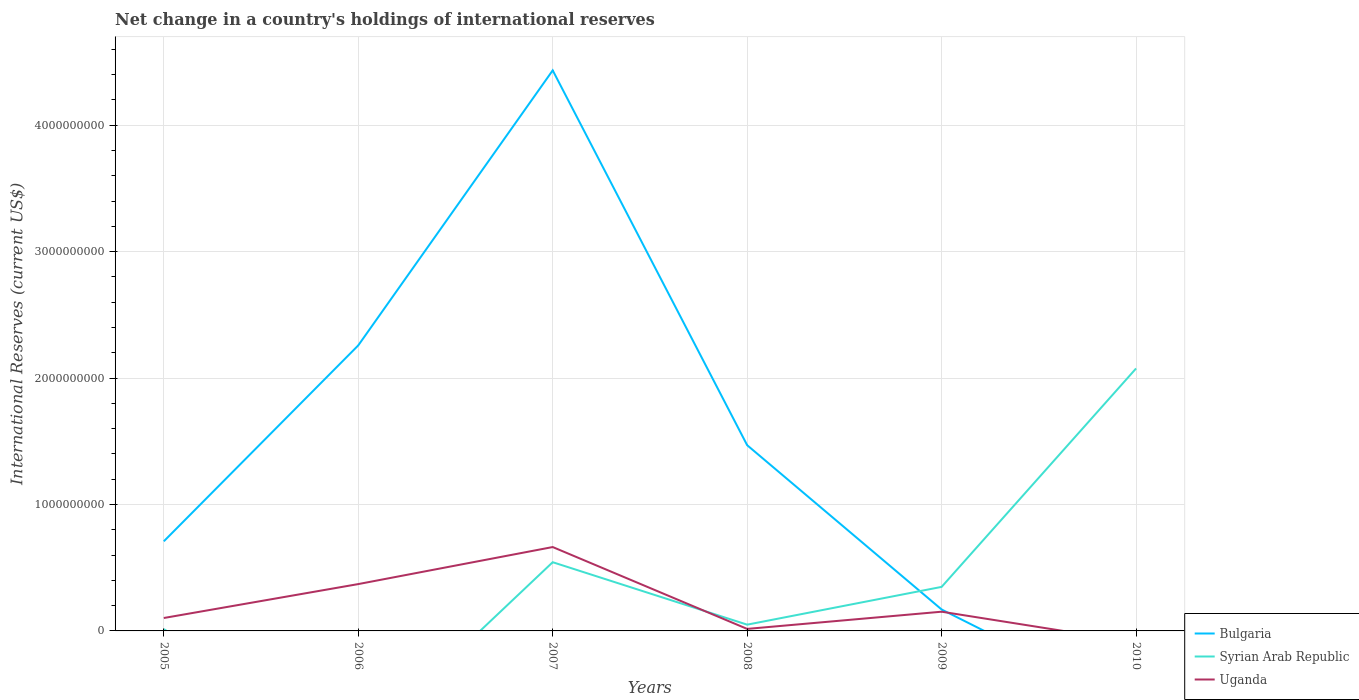Does the line corresponding to Syrian Arab Republic intersect with the line corresponding to Bulgaria?
Provide a succinct answer. Yes. Is the number of lines equal to the number of legend labels?
Provide a short and direct response. No. Across all years, what is the maximum international reserves in Uganda?
Keep it short and to the point. 0. What is the total international reserves in Syrian Arab Republic in the graph?
Keep it short and to the point. -3.56e+07. What is the difference between the highest and the second highest international reserves in Uganda?
Make the answer very short. 6.64e+08. Is the international reserves in Bulgaria strictly greater than the international reserves in Syrian Arab Republic over the years?
Make the answer very short. No. How many years are there in the graph?
Provide a succinct answer. 6. Are the values on the major ticks of Y-axis written in scientific E-notation?
Give a very brief answer. No. Does the graph contain any zero values?
Ensure brevity in your answer.  Yes. Where does the legend appear in the graph?
Offer a very short reply. Bottom right. How many legend labels are there?
Your answer should be compact. 3. How are the legend labels stacked?
Offer a very short reply. Vertical. What is the title of the graph?
Provide a succinct answer. Net change in a country's holdings of international reserves. Does "French Polynesia" appear as one of the legend labels in the graph?
Offer a very short reply. No. What is the label or title of the X-axis?
Ensure brevity in your answer.  Years. What is the label or title of the Y-axis?
Offer a terse response. International Reserves (current US$). What is the International Reserves (current US$) in Bulgaria in 2005?
Offer a very short reply. 7.09e+08. What is the International Reserves (current US$) of Syrian Arab Republic in 2005?
Ensure brevity in your answer.  1.40e+07. What is the International Reserves (current US$) of Uganda in 2005?
Give a very brief answer. 1.02e+08. What is the International Reserves (current US$) of Bulgaria in 2006?
Your response must be concise. 2.26e+09. What is the International Reserves (current US$) in Uganda in 2006?
Give a very brief answer. 3.70e+08. What is the International Reserves (current US$) in Bulgaria in 2007?
Provide a short and direct response. 4.43e+09. What is the International Reserves (current US$) of Syrian Arab Republic in 2007?
Ensure brevity in your answer.  5.44e+08. What is the International Reserves (current US$) in Uganda in 2007?
Your response must be concise. 6.64e+08. What is the International Reserves (current US$) in Bulgaria in 2008?
Offer a very short reply. 1.47e+09. What is the International Reserves (current US$) of Syrian Arab Republic in 2008?
Ensure brevity in your answer.  4.96e+07. What is the International Reserves (current US$) in Uganda in 2008?
Offer a terse response. 1.59e+07. What is the International Reserves (current US$) of Bulgaria in 2009?
Provide a short and direct response. 1.69e+08. What is the International Reserves (current US$) in Syrian Arab Republic in 2009?
Offer a very short reply. 3.48e+08. What is the International Reserves (current US$) of Uganda in 2009?
Make the answer very short. 1.52e+08. What is the International Reserves (current US$) in Bulgaria in 2010?
Your response must be concise. 0. What is the International Reserves (current US$) in Syrian Arab Republic in 2010?
Make the answer very short. 2.08e+09. Across all years, what is the maximum International Reserves (current US$) in Bulgaria?
Offer a terse response. 4.43e+09. Across all years, what is the maximum International Reserves (current US$) of Syrian Arab Republic?
Offer a very short reply. 2.08e+09. Across all years, what is the maximum International Reserves (current US$) of Uganda?
Ensure brevity in your answer.  6.64e+08. Across all years, what is the minimum International Reserves (current US$) of Bulgaria?
Provide a short and direct response. 0. Across all years, what is the minimum International Reserves (current US$) in Syrian Arab Republic?
Offer a terse response. 0. Across all years, what is the minimum International Reserves (current US$) in Uganda?
Ensure brevity in your answer.  0. What is the total International Reserves (current US$) of Bulgaria in the graph?
Ensure brevity in your answer.  9.04e+09. What is the total International Reserves (current US$) of Syrian Arab Republic in the graph?
Your response must be concise. 3.03e+09. What is the total International Reserves (current US$) of Uganda in the graph?
Keep it short and to the point. 1.30e+09. What is the difference between the International Reserves (current US$) in Bulgaria in 2005 and that in 2006?
Keep it short and to the point. -1.55e+09. What is the difference between the International Reserves (current US$) of Uganda in 2005 and that in 2006?
Provide a succinct answer. -2.68e+08. What is the difference between the International Reserves (current US$) of Bulgaria in 2005 and that in 2007?
Give a very brief answer. -3.73e+09. What is the difference between the International Reserves (current US$) in Syrian Arab Republic in 2005 and that in 2007?
Your answer should be very brief. -5.30e+08. What is the difference between the International Reserves (current US$) of Uganda in 2005 and that in 2007?
Offer a very short reply. -5.61e+08. What is the difference between the International Reserves (current US$) in Bulgaria in 2005 and that in 2008?
Ensure brevity in your answer.  -7.60e+08. What is the difference between the International Reserves (current US$) of Syrian Arab Republic in 2005 and that in 2008?
Give a very brief answer. -3.56e+07. What is the difference between the International Reserves (current US$) in Uganda in 2005 and that in 2008?
Offer a terse response. 8.63e+07. What is the difference between the International Reserves (current US$) in Bulgaria in 2005 and that in 2009?
Offer a terse response. 5.39e+08. What is the difference between the International Reserves (current US$) in Syrian Arab Republic in 2005 and that in 2009?
Make the answer very short. -3.34e+08. What is the difference between the International Reserves (current US$) in Uganda in 2005 and that in 2009?
Provide a succinct answer. -4.98e+07. What is the difference between the International Reserves (current US$) in Syrian Arab Republic in 2005 and that in 2010?
Your answer should be compact. -2.06e+09. What is the difference between the International Reserves (current US$) in Bulgaria in 2006 and that in 2007?
Ensure brevity in your answer.  -2.18e+09. What is the difference between the International Reserves (current US$) of Uganda in 2006 and that in 2007?
Your response must be concise. -2.93e+08. What is the difference between the International Reserves (current US$) of Bulgaria in 2006 and that in 2008?
Make the answer very short. 7.89e+08. What is the difference between the International Reserves (current US$) in Uganda in 2006 and that in 2008?
Provide a succinct answer. 3.55e+08. What is the difference between the International Reserves (current US$) in Bulgaria in 2006 and that in 2009?
Give a very brief answer. 2.09e+09. What is the difference between the International Reserves (current US$) in Uganda in 2006 and that in 2009?
Offer a very short reply. 2.19e+08. What is the difference between the International Reserves (current US$) of Bulgaria in 2007 and that in 2008?
Provide a succinct answer. 2.97e+09. What is the difference between the International Reserves (current US$) of Syrian Arab Republic in 2007 and that in 2008?
Give a very brief answer. 4.94e+08. What is the difference between the International Reserves (current US$) in Uganda in 2007 and that in 2008?
Make the answer very short. 6.48e+08. What is the difference between the International Reserves (current US$) of Bulgaria in 2007 and that in 2009?
Provide a succinct answer. 4.26e+09. What is the difference between the International Reserves (current US$) of Syrian Arab Republic in 2007 and that in 2009?
Your answer should be very brief. 1.95e+08. What is the difference between the International Reserves (current US$) in Uganda in 2007 and that in 2009?
Your answer should be very brief. 5.12e+08. What is the difference between the International Reserves (current US$) of Syrian Arab Republic in 2007 and that in 2010?
Offer a terse response. -1.53e+09. What is the difference between the International Reserves (current US$) in Bulgaria in 2008 and that in 2009?
Provide a succinct answer. 1.30e+09. What is the difference between the International Reserves (current US$) in Syrian Arab Republic in 2008 and that in 2009?
Provide a short and direct response. -2.99e+08. What is the difference between the International Reserves (current US$) in Uganda in 2008 and that in 2009?
Provide a short and direct response. -1.36e+08. What is the difference between the International Reserves (current US$) in Syrian Arab Republic in 2008 and that in 2010?
Your response must be concise. -2.03e+09. What is the difference between the International Reserves (current US$) in Syrian Arab Republic in 2009 and that in 2010?
Provide a succinct answer. -1.73e+09. What is the difference between the International Reserves (current US$) in Bulgaria in 2005 and the International Reserves (current US$) in Uganda in 2006?
Give a very brief answer. 3.38e+08. What is the difference between the International Reserves (current US$) in Syrian Arab Republic in 2005 and the International Reserves (current US$) in Uganda in 2006?
Offer a very short reply. -3.57e+08. What is the difference between the International Reserves (current US$) in Bulgaria in 2005 and the International Reserves (current US$) in Syrian Arab Republic in 2007?
Provide a succinct answer. 1.65e+08. What is the difference between the International Reserves (current US$) in Bulgaria in 2005 and the International Reserves (current US$) in Uganda in 2007?
Your answer should be very brief. 4.52e+07. What is the difference between the International Reserves (current US$) of Syrian Arab Republic in 2005 and the International Reserves (current US$) of Uganda in 2007?
Ensure brevity in your answer.  -6.50e+08. What is the difference between the International Reserves (current US$) in Bulgaria in 2005 and the International Reserves (current US$) in Syrian Arab Republic in 2008?
Offer a very short reply. 6.59e+08. What is the difference between the International Reserves (current US$) in Bulgaria in 2005 and the International Reserves (current US$) in Uganda in 2008?
Offer a terse response. 6.93e+08. What is the difference between the International Reserves (current US$) of Syrian Arab Republic in 2005 and the International Reserves (current US$) of Uganda in 2008?
Give a very brief answer. -1.92e+06. What is the difference between the International Reserves (current US$) in Bulgaria in 2005 and the International Reserves (current US$) in Syrian Arab Republic in 2009?
Ensure brevity in your answer.  3.60e+08. What is the difference between the International Reserves (current US$) in Bulgaria in 2005 and the International Reserves (current US$) in Uganda in 2009?
Give a very brief answer. 5.57e+08. What is the difference between the International Reserves (current US$) of Syrian Arab Republic in 2005 and the International Reserves (current US$) of Uganda in 2009?
Provide a succinct answer. -1.38e+08. What is the difference between the International Reserves (current US$) of Bulgaria in 2005 and the International Reserves (current US$) of Syrian Arab Republic in 2010?
Your answer should be compact. -1.37e+09. What is the difference between the International Reserves (current US$) in Bulgaria in 2006 and the International Reserves (current US$) in Syrian Arab Republic in 2007?
Offer a terse response. 1.72e+09. What is the difference between the International Reserves (current US$) of Bulgaria in 2006 and the International Reserves (current US$) of Uganda in 2007?
Your response must be concise. 1.60e+09. What is the difference between the International Reserves (current US$) of Bulgaria in 2006 and the International Reserves (current US$) of Syrian Arab Republic in 2008?
Give a very brief answer. 2.21e+09. What is the difference between the International Reserves (current US$) in Bulgaria in 2006 and the International Reserves (current US$) in Uganda in 2008?
Offer a terse response. 2.24e+09. What is the difference between the International Reserves (current US$) in Bulgaria in 2006 and the International Reserves (current US$) in Syrian Arab Republic in 2009?
Make the answer very short. 1.91e+09. What is the difference between the International Reserves (current US$) of Bulgaria in 2006 and the International Reserves (current US$) of Uganda in 2009?
Provide a succinct answer. 2.11e+09. What is the difference between the International Reserves (current US$) in Bulgaria in 2006 and the International Reserves (current US$) in Syrian Arab Republic in 2010?
Give a very brief answer. 1.82e+08. What is the difference between the International Reserves (current US$) in Bulgaria in 2007 and the International Reserves (current US$) in Syrian Arab Republic in 2008?
Make the answer very short. 4.38e+09. What is the difference between the International Reserves (current US$) in Bulgaria in 2007 and the International Reserves (current US$) in Uganda in 2008?
Your answer should be compact. 4.42e+09. What is the difference between the International Reserves (current US$) of Syrian Arab Republic in 2007 and the International Reserves (current US$) of Uganda in 2008?
Keep it short and to the point. 5.28e+08. What is the difference between the International Reserves (current US$) of Bulgaria in 2007 and the International Reserves (current US$) of Syrian Arab Republic in 2009?
Provide a succinct answer. 4.09e+09. What is the difference between the International Reserves (current US$) of Bulgaria in 2007 and the International Reserves (current US$) of Uganda in 2009?
Your response must be concise. 4.28e+09. What is the difference between the International Reserves (current US$) of Syrian Arab Republic in 2007 and the International Reserves (current US$) of Uganda in 2009?
Keep it short and to the point. 3.92e+08. What is the difference between the International Reserves (current US$) in Bulgaria in 2007 and the International Reserves (current US$) in Syrian Arab Republic in 2010?
Keep it short and to the point. 2.36e+09. What is the difference between the International Reserves (current US$) in Bulgaria in 2008 and the International Reserves (current US$) in Syrian Arab Republic in 2009?
Your answer should be very brief. 1.12e+09. What is the difference between the International Reserves (current US$) of Bulgaria in 2008 and the International Reserves (current US$) of Uganda in 2009?
Provide a succinct answer. 1.32e+09. What is the difference between the International Reserves (current US$) of Syrian Arab Republic in 2008 and the International Reserves (current US$) of Uganda in 2009?
Provide a short and direct response. -1.02e+08. What is the difference between the International Reserves (current US$) in Bulgaria in 2008 and the International Reserves (current US$) in Syrian Arab Republic in 2010?
Ensure brevity in your answer.  -6.07e+08. What is the difference between the International Reserves (current US$) in Bulgaria in 2009 and the International Reserves (current US$) in Syrian Arab Republic in 2010?
Ensure brevity in your answer.  -1.91e+09. What is the average International Reserves (current US$) in Bulgaria per year?
Your response must be concise. 1.51e+09. What is the average International Reserves (current US$) of Syrian Arab Republic per year?
Your answer should be compact. 5.05e+08. What is the average International Reserves (current US$) in Uganda per year?
Keep it short and to the point. 2.17e+08. In the year 2005, what is the difference between the International Reserves (current US$) in Bulgaria and International Reserves (current US$) in Syrian Arab Republic?
Ensure brevity in your answer.  6.95e+08. In the year 2005, what is the difference between the International Reserves (current US$) in Bulgaria and International Reserves (current US$) in Uganda?
Your answer should be very brief. 6.07e+08. In the year 2005, what is the difference between the International Reserves (current US$) in Syrian Arab Republic and International Reserves (current US$) in Uganda?
Provide a succinct answer. -8.82e+07. In the year 2006, what is the difference between the International Reserves (current US$) of Bulgaria and International Reserves (current US$) of Uganda?
Offer a very short reply. 1.89e+09. In the year 2007, what is the difference between the International Reserves (current US$) of Bulgaria and International Reserves (current US$) of Syrian Arab Republic?
Offer a very short reply. 3.89e+09. In the year 2007, what is the difference between the International Reserves (current US$) in Bulgaria and International Reserves (current US$) in Uganda?
Provide a short and direct response. 3.77e+09. In the year 2007, what is the difference between the International Reserves (current US$) in Syrian Arab Republic and International Reserves (current US$) in Uganda?
Your answer should be very brief. -1.20e+08. In the year 2008, what is the difference between the International Reserves (current US$) in Bulgaria and International Reserves (current US$) in Syrian Arab Republic?
Keep it short and to the point. 1.42e+09. In the year 2008, what is the difference between the International Reserves (current US$) of Bulgaria and International Reserves (current US$) of Uganda?
Keep it short and to the point. 1.45e+09. In the year 2008, what is the difference between the International Reserves (current US$) of Syrian Arab Republic and International Reserves (current US$) of Uganda?
Ensure brevity in your answer.  3.36e+07. In the year 2009, what is the difference between the International Reserves (current US$) in Bulgaria and International Reserves (current US$) in Syrian Arab Republic?
Provide a succinct answer. -1.79e+08. In the year 2009, what is the difference between the International Reserves (current US$) of Bulgaria and International Reserves (current US$) of Uganda?
Provide a short and direct response. 1.75e+07. In the year 2009, what is the difference between the International Reserves (current US$) in Syrian Arab Republic and International Reserves (current US$) in Uganda?
Your answer should be compact. 1.96e+08. What is the ratio of the International Reserves (current US$) of Bulgaria in 2005 to that in 2006?
Ensure brevity in your answer.  0.31. What is the ratio of the International Reserves (current US$) of Uganda in 2005 to that in 2006?
Your answer should be very brief. 0.28. What is the ratio of the International Reserves (current US$) in Bulgaria in 2005 to that in 2007?
Your answer should be very brief. 0.16. What is the ratio of the International Reserves (current US$) of Syrian Arab Republic in 2005 to that in 2007?
Provide a succinct answer. 0.03. What is the ratio of the International Reserves (current US$) in Uganda in 2005 to that in 2007?
Provide a short and direct response. 0.15. What is the ratio of the International Reserves (current US$) of Bulgaria in 2005 to that in 2008?
Keep it short and to the point. 0.48. What is the ratio of the International Reserves (current US$) in Syrian Arab Republic in 2005 to that in 2008?
Offer a terse response. 0.28. What is the ratio of the International Reserves (current US$) of Uganda in 2005 to that in 2008?
Your answer should be very brief. 6.42. What is the ratio of the International Reserves (current US$) in Bulgaria in 2005 to that in 2009?
Offer a very short reply. 4.18. What is the ratio of the International Reserves (current US$) in Syrian Arab Republic in 2005 to that in 2009?
Your answer should be compact. 0.04. What is the ratio of the International Reserves (current US$) in Uganda in 2005 to that in 2009?
Keep it short and to the point. 0.67. What is the ratio of the International Reserves (current US$) of Syrian Arab Republic in 2005 to that in 2010?
Your response must be concise. 0.01. What is the ratio of the International Reserves (current US$) of Bulgaria in 2006 to that in 2007?
Offer a terse response. 0.51. What is the ratio of the International Reserves (current US$) of Uganda in 2006 to that in 2007?
Provide a succinct answer. 0.56. What is the ratio of the International Reserves (current US$) of Bulgaria in 2006 to that in 2008?
Keep it short and to the point. 1.54. What is the ratio of the International Reserves (current US$) in Uganda in 2006 to that in 2008?
Your response must be concise. 23.27. What is the ratio of the International Reserves (current US$) of Bulgaria in 2006 to that in 2009?
Offer a very short reply. 13.33. What is the ratio of the International Reserves (current US$) in Uganda in 2006 to that in 2009?
Keep it short and to the point. 2.44. What is the ratio of the International Reserves (current US$) of Bulgaria in 2007 to that in 2008?
Your answer should be compact. 3.02. What is the ratio of the International Reserves (current US$) in Syrian Arab Republic in 2007 to that in 2008?
Your answer should be very brief. 10.97. What is the ratio of the International Reserves (current US$) in Uganda in 2007 to that in 2008?
Offer a very short reply. 41.68. What is the ratio of the International Reserves (current US$) of Bulgaria in 2007 to that in 2009?
Offer a very short reply. 26.16. What is the ratio of the International Reserves (current US$) of Syrian Arab Republic in 2007 to that in 2009?
Provide a succinct answer. 1.56. What is the ratio of the International Reserves (current US$) in Uganda in 2007 to that in 2009?
Give a very brief answer. 4.37. What is the ratio of the International Reserves (current US$) in Syrian Arab Republic in 2007 to that in 2010?
Keep it short and to the point. 0.26. What is the ratio of the International Reserves (current US$) of Bulgaria in 2008 to that in 2009?
Ensure brevity in your answer.  8.67. What is the ratio of the International Reserves (current US$) of Syrian Arab Republic in 2008 to that in 2009?
Offer a terse response. 0.14. What is the ratio of the International Reserves (current US$) in Uganda in 2008 to that in 2009?
Offer a very short reply. 0.1. What is the ratio of the International Reserves (current US$) in Syrian Arab Republic in 2008 to that in 2010?
Offer a very short reply. 0.02. What is the ratio of the International Reserves (current US$) in Syrian Arab Republic in 2009 to that in 2010?
Keep it short and to the point. 0.17. What is the difference between the highest and the second highest International Reserves (current US$) of Bulgaria?
Keep it short and to the point. 2.18e+09. What is the difference between the highest and the second highest International Reserves (current US$) of Syrian Arab Republic?
Provide a succinct answer. 1.53e+09. What is the difference between the highest and the second highest International Reserves (current US$) of Uganda?
Provide a short and direct response. 2.93e+08. What is the difference between the highest and the lowest International Reserves (current US$) in Bulgaria?
Offer a very short reply. 4.43e+09. What is the difference between the highest and the lowest International Reserves (current US$) in Syrian Arab Republic?
Your answer should be compact. 2.08e+09. What is the difference between the highest and the lowest International Reserves (current US$) in Uganda?
Keep it short and to the point. 6.64e+08. 